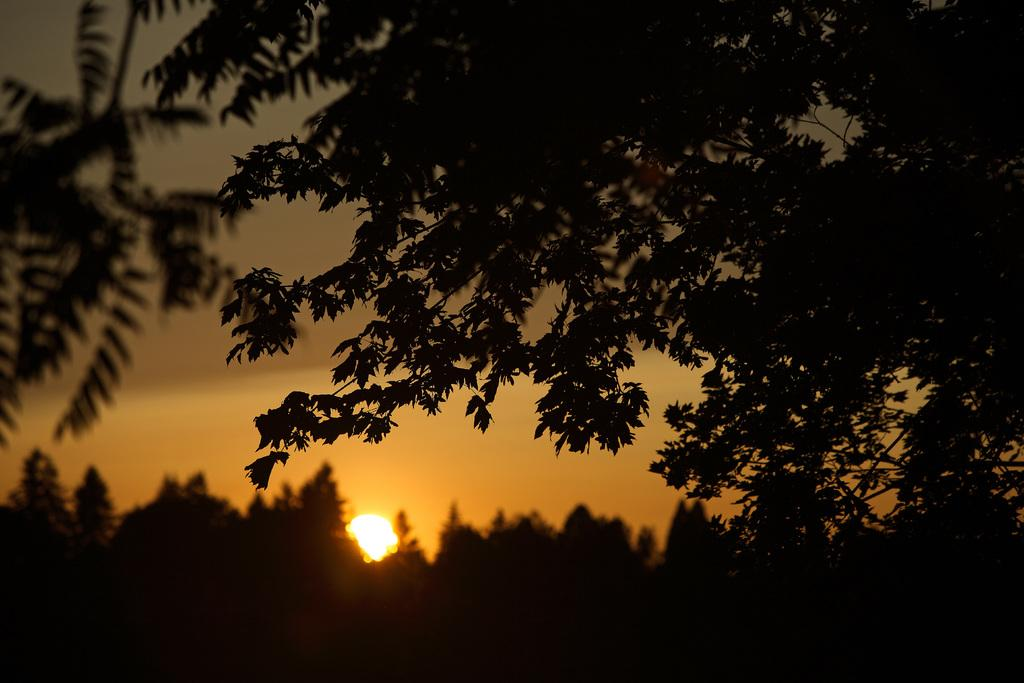What is located at the bottom of the image? The sun is at the bottom side of the image. What type of natural elements can be seen in the image? There are trees around the area of the image. What time is displayed on the clock in the image? There is no clock present in the image. What is the daughter learning in the image? There is no daughter or learning activity depicted in the image. 